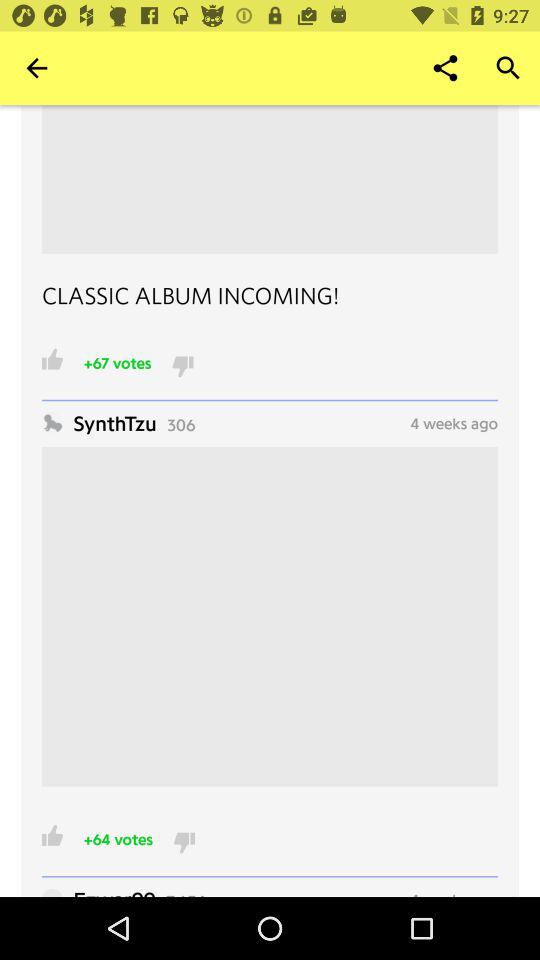Which applications are available for sharing?
When the provided information is insufficient, respond with <no answer>. <no answer> 